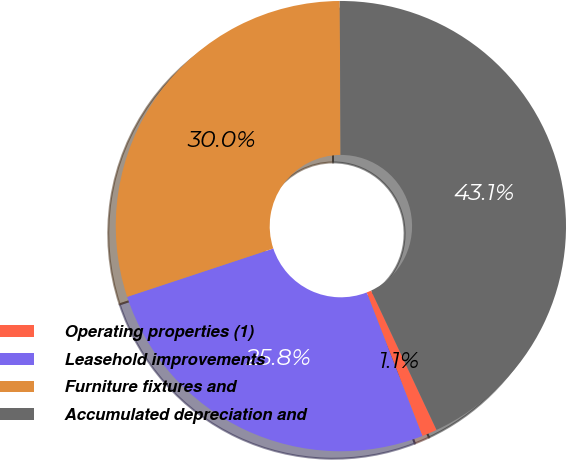Convert chart to OTSL. <chart><loc_0><loc_0><loc_500><loc_500><pie_chart><fcel>Operating properties (1)<fcel>Leasehold improvements<fcel>Furniture fixtures and<fcel>Accumulated depreciation and<nl><fcel>1.09%<fcel>25.81%<fcel>30.01%<fcel>43.1%<nl></chart> 